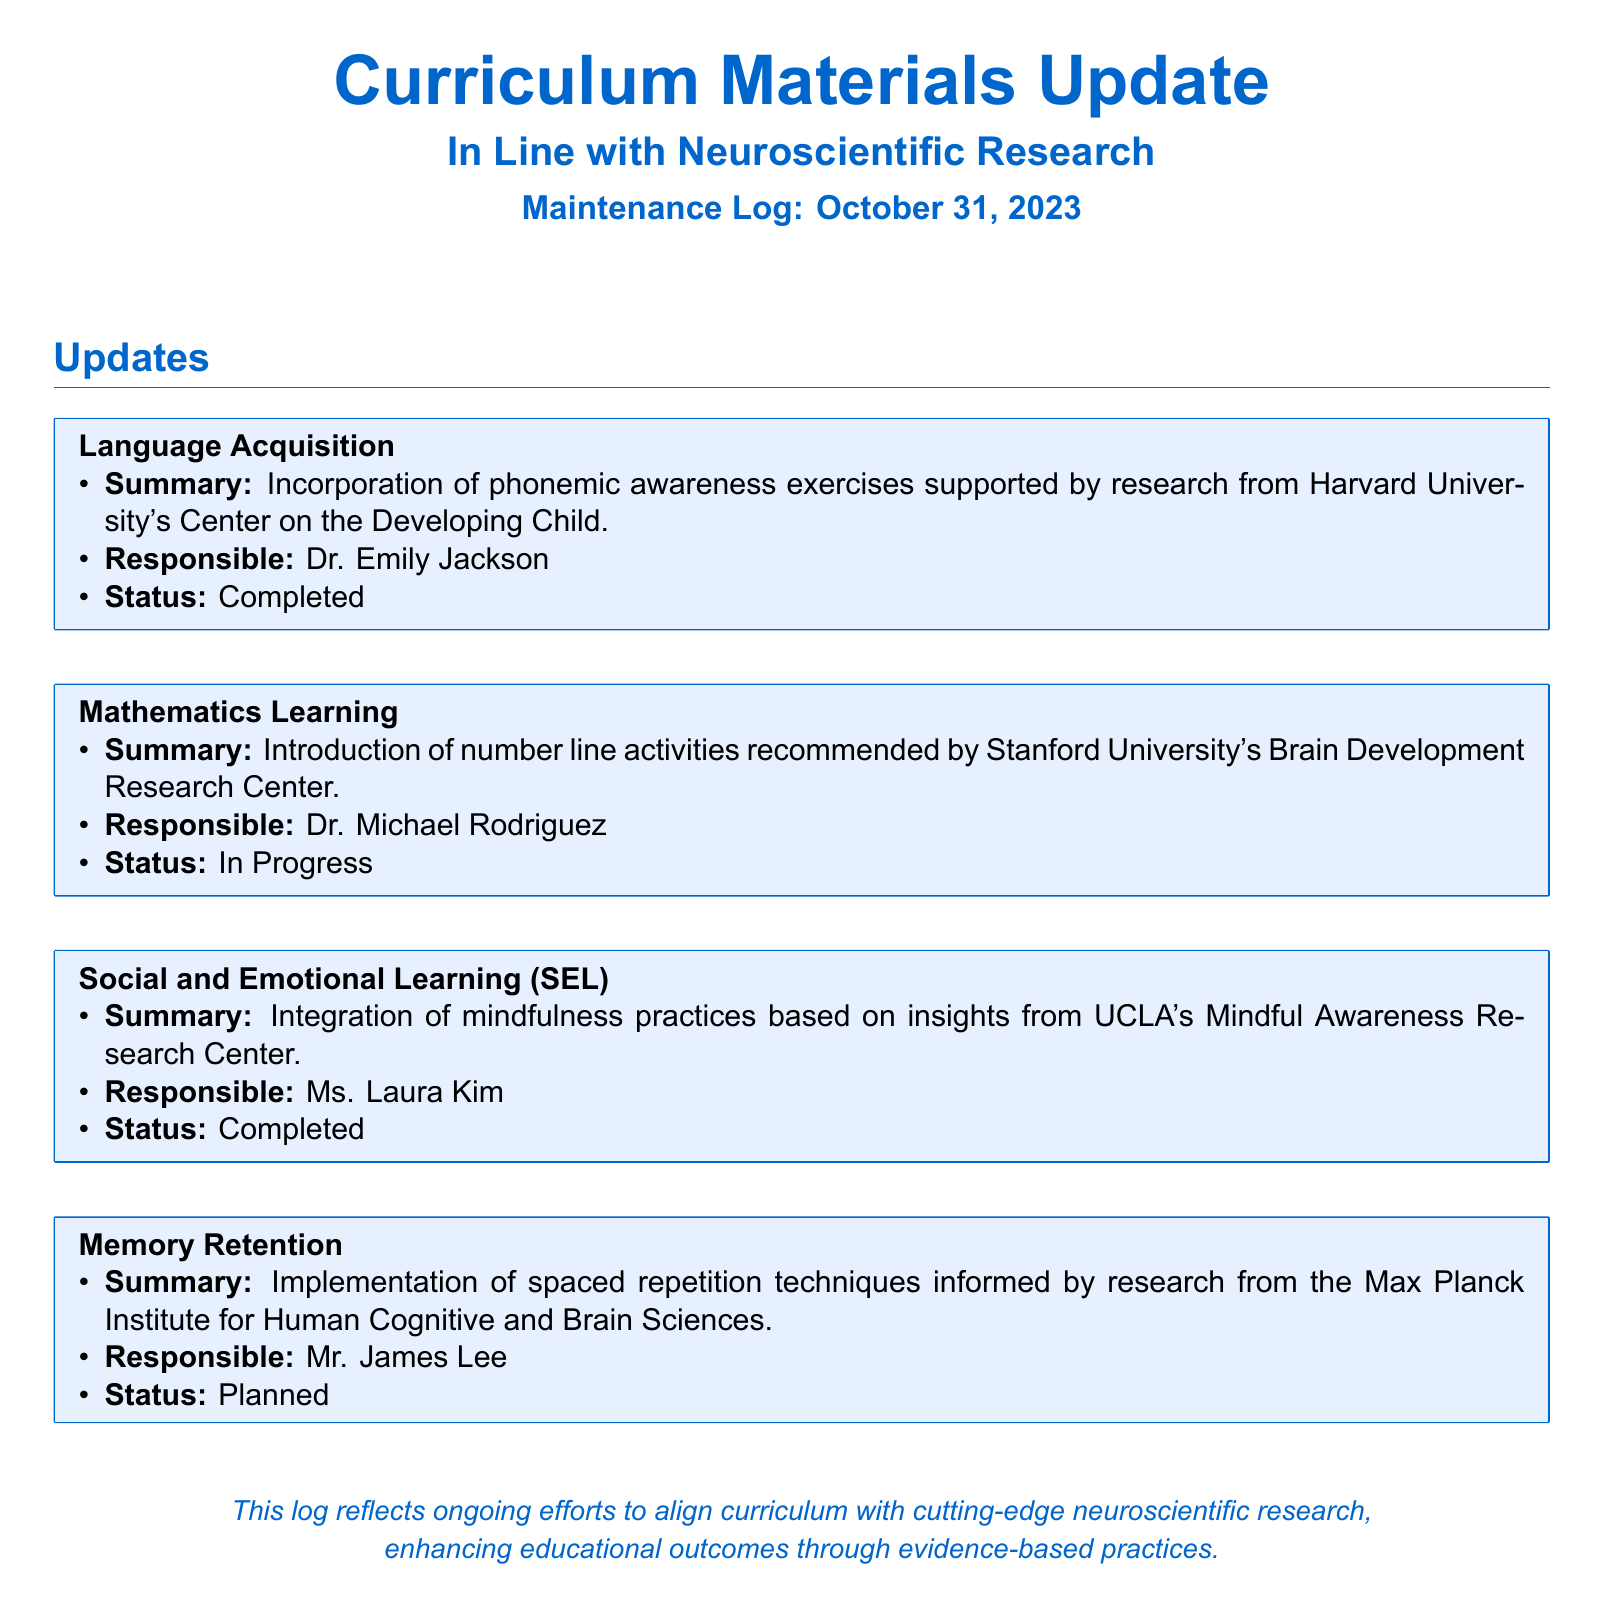What is the update related to Language Acquisition? The update discusses the incorporation of phonemic awareness exercises supported by research.
Answer: Incorporation of phonemic awareness exercises Who is responsible for the Mathematics Learning update? The document states that Dr. Michael Rodriguez is responsible for the Mathematics Learning update.
Answer: Dr. Michael Rodriguez What is the status of the Memory Retention implementation? The status indicates that the implementation of spaced repetition techniques is planned.
Answer: Planned Which institution is associated with the Social and Emotional Learning update? The update on Social and Emotional Learning is based on insights from UCLA's Mindful Awareness Research Center.
Answer: UCLA's Mindful Awareness Research Center What type of learning activity is being introduced in Mathematics Learning? The update mentions the introduction of number line activities.
Answer: Number line activities How many updates are completed according to the log? There are three updates marked as completed in the log.
Answer: Three What is the focus of the Memory Retention update? The focus of the Memory Retention update is on spaced repetition techniques.
Answer: Spaced repetition techniques When was the Maintenance Log updated? The log was updated on October 31, 2023.
Answer: October 31, 2023 What is the overall purpose of this maintenance log? The log reflects ongoing efforts to align curriculum with neuroscientific research, enhancing educational outcomes.
Answer: Align curriculum with neuroscientific research 